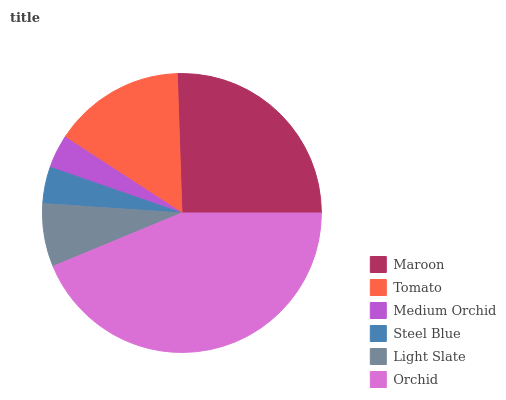Is Medium Orchid the minimum?
Answer yes or no. Yes. Is Orchid the maximum?
Answer yes or no. Yes. Is Tomato the minimum?
Answer yes or no. No. Is Tomato the maximum?
Answer yes or no. No. Is Maroon greater than Tomato?
Answer yes or no. Yes. Is Tomato less than Maroon?
Answer yes or no. Yes. Is Tomato greater than Maroon?
Answer yes or no. No. Is Maroon less than Tomato?
Answer yes or no. No. Is Tomato the high median?
Answer yes or no. Yes. Is Light Slate the low median?
Answer yes or no. Yes. Is Medium Orchid the high median?
Answer yes or no. No. Is Medium Orchid the low median?
Answer yes or no. No. 